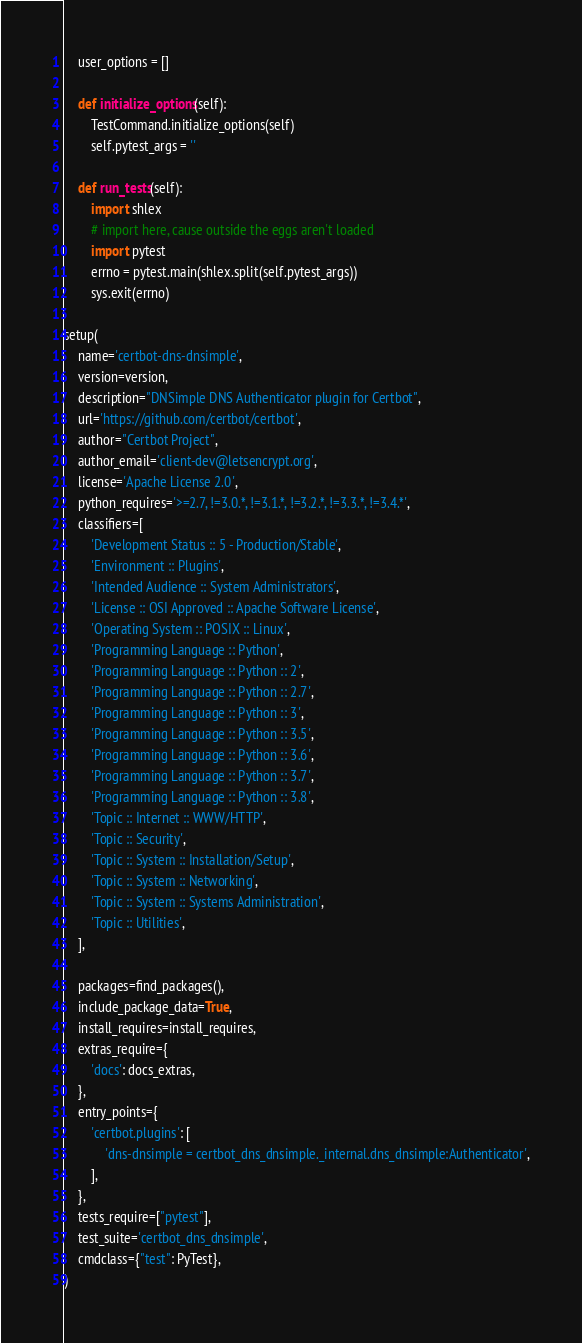<code> <loc_0><loc_0><loc_500><loc_500><_Python_>    user_options = []

    def initialize_options(self):
        TestCommand.initialize_options(self)
        self.pytest_args = ''

    def run_tests(self):
        import shlex
        # import here, cause outside the eggs aren't loaded
        import pytest
        errno = pytest.main(shlex.split(self.pytest_args))
        sys.exit(errno)

setup(
    name='certbot-dns-dnsimple',
    version=version,
    description="DNSimple DNS Authenticator plugin for Certbot",
    url='https://github.com/certbot/certbot',
    author="Certbot Project",
    author_email='client-dev@letsencrypt.org',
    license='Apache License 2.0',
    python_requires='>=2.7, !=3.0.*, !=3.1.*, !=3.2.*, !=3.3.*, !=3.4.*',
    classifiers=[
        'Development Status :: 5 - Production/Stable',
        'Environment :: Plugins',
        'Intended Audience :: System Administrators',
        'License :: OSI Approved :: Apache Software License',
        'Operating System :: POSIX :: Linux',
        'Programming Language :: Python',
        'Programming Language :: Python :: 2',
        'Programming Language :: Python :: 2.7',
        'Programming Language :: Python :: 3',
        'Programming Language :: Python :: 3.5',
        'Programming Language :: Python :: 3.6',
        'Programming Language :: Python :: 3.7',
        'Programming Language :: Python :: 3.8',
        'Topic :: Internet :: WWW/HTTP',
        'Topic :: Security',
        'Topic :: System :: Installation/Setup',
        'Topic :: System :: Networking',
        'Topic :: System :: Systems Administration',
        'Topic :: Utilities',
    ],

    packages=find_packages(),
    include_package_data=True,
    install_requires=install_requires,
    extras_require={
        'docs': docs_extras,
    },
    entry_points={
        'certbot.plugins': [
            'dns-dnsimple = certbot_dns_dnsimple._internal.dns_dnsimple:Authenticator',
        ],
    },
    tests_require=["pytest"],
    test_suite='certbot_dns_dnsimple',
    cmdclass={"test": PyTest},
)
</code> 